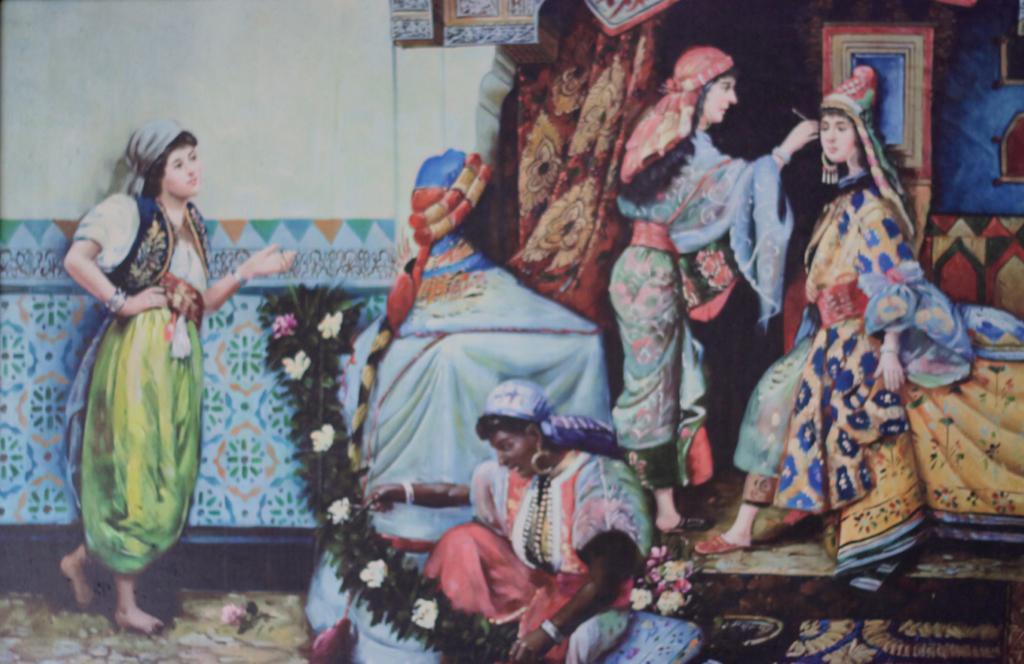Could you give a brief overview of what you see in this image? This picture shows a painting. we see painting of few women. 